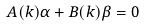<formula> <loc_0><loc_0><loc_500><loc_500>A ( k ) \alpha + B ( k ) \beta = 0</formula> 